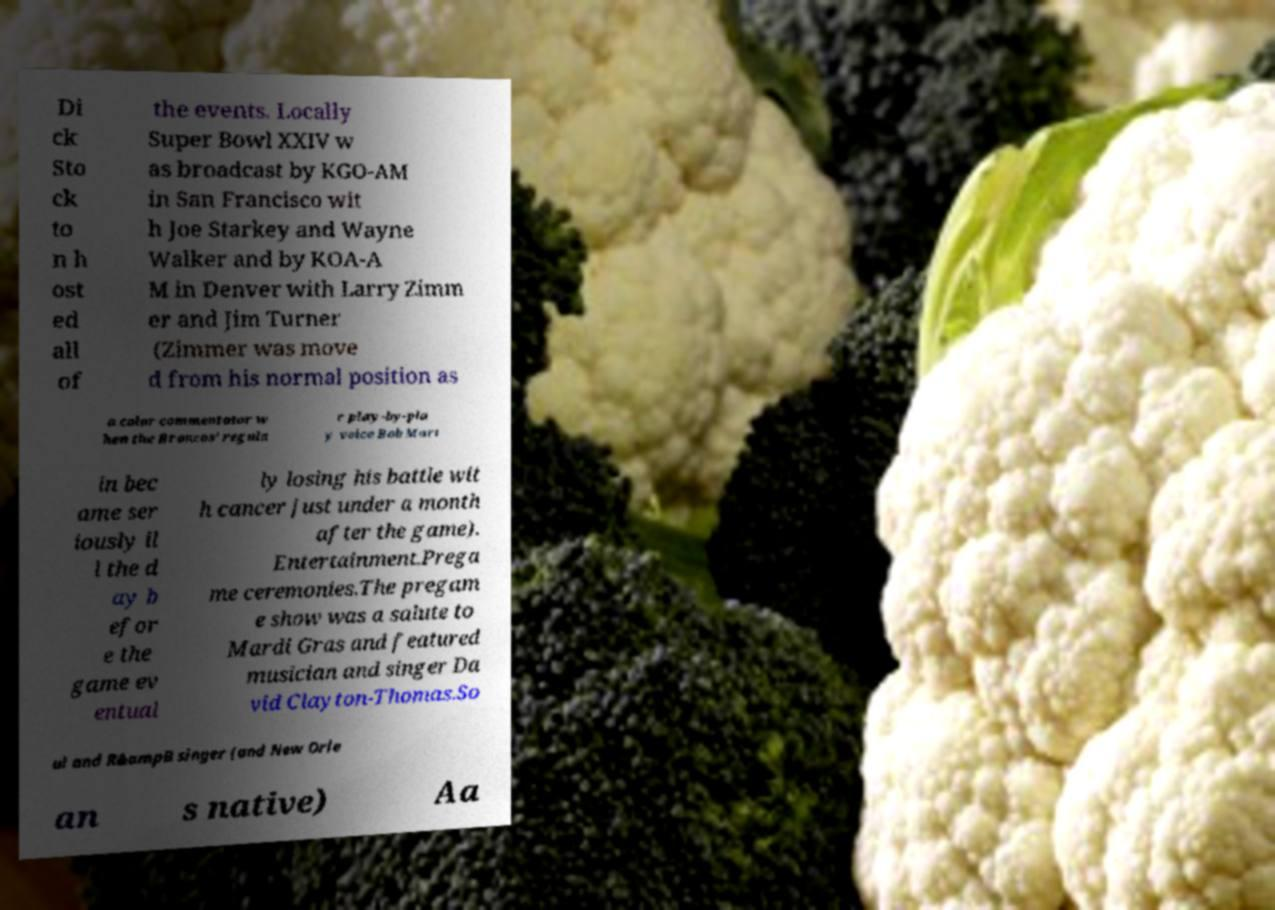Can you read and provide the text displayed in the image?This photo seems to have some interesting text. Can you extract and type it out for me? Di ck Sto ck to n h ost ed all of the events. Locally Super Bowl XXIV w as broadcast by KGO-AM in San Francisco wit h Joe Starkey and Wayne Walker and by KOA-A M in Denver with Larry Zimm er and Jim Turner (Zimmer was move d from his normal position as a color commentator w hen the Broncos' regula r play-by-pla y voice Bob Mart in bec ame ser iously il l the d ay b efor e the game ev entual ly losing his battle wit h cancer just under a month after the game). Entertainment.Prega me ceremonies.The pregam e show was a salute to Mardi Gras and featured musician and singer Da vid Clayton-Thomas.So ul and R&ampB singer (and New Orle an s native) Aa 